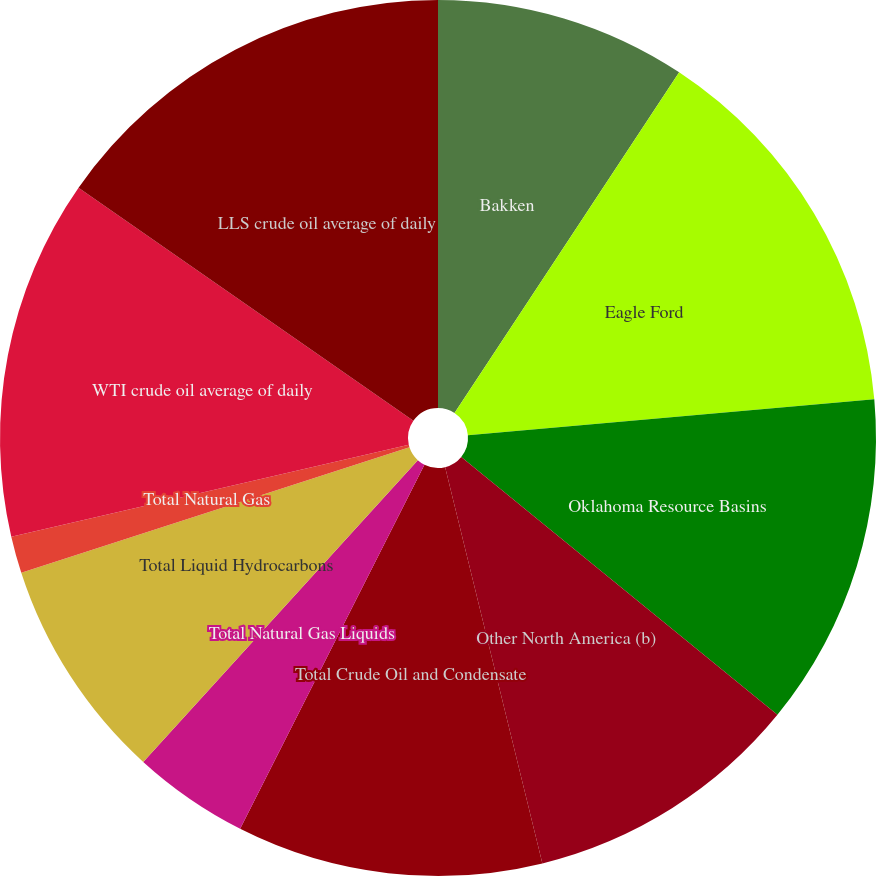Convert chart. <chart><loc_0><loc_0><loc_500><loc_500><pie_chart><fcel>Bakken<fcel>Eagle Ford<fcel>Oklahoma Resource Basins<fcel>Other North America (b)<fcel>Total Crude Oil and Condensate<fcel>Total Natural Gas Liquids<fcel>Total Liquid Hydrocarbons<fcel>Total Natural Gas<fcel>WTI crude oil average of daily<fcel>LLS crude oil average of daily<nl><fcel>9.28%<fcel>14.31%<fcel>12.3%<fcel>10.28%<fcel>11.29%<fcel>4.29%<fcel>8.27%<fcel>1.36%<fcel>13.3%<fcel>15.32%<nl></chart> 